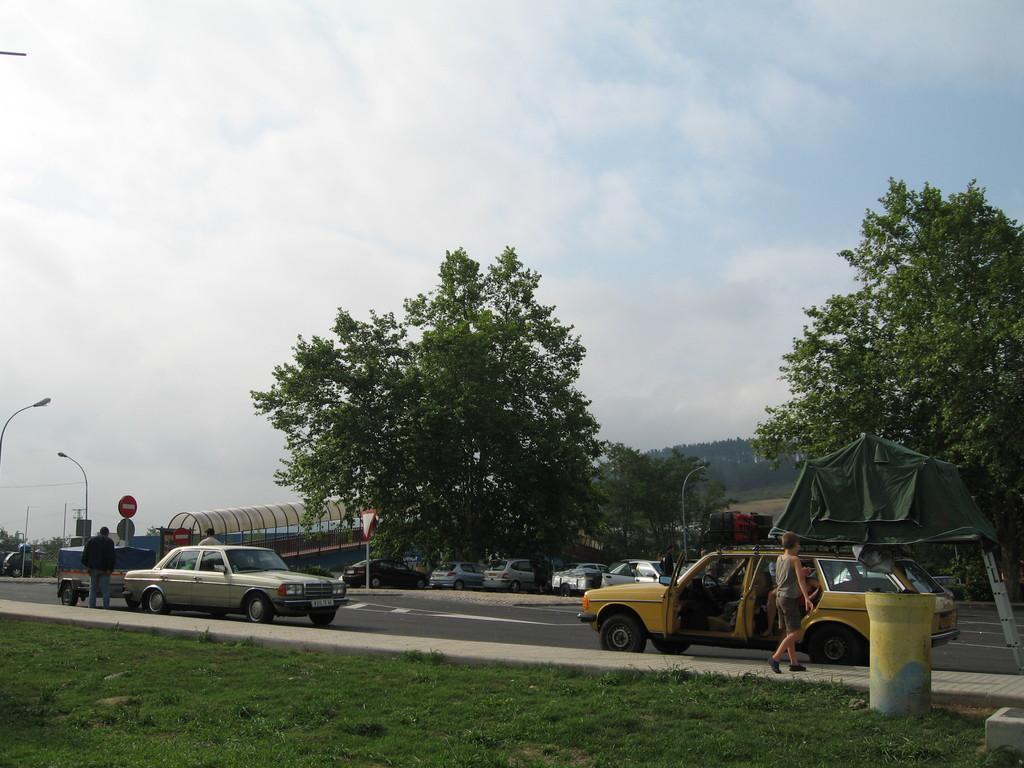Please provide a concise description of this image. This image is taken outdoors. At the top of the image there is the sky with clouds. At the bottom of the image there is a ground with grass on it. In the background there are a few trees. In the middle of the image there are a few trees with leaves, stems and branches. There is a tent. A few cars are parked on the ground. There is a signboard. There is an architecture. There are a few poles with street lights. A man is standing on the road and a few cars are parked on the road. A boy is walking on the sidewalk and there is an object on the ground. 